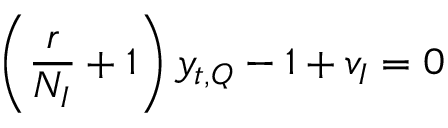<formula> <loc_0><loc_0><loc_500><loc_500>\left ( \frac { r } { N _ { I } } + 1 \right ) y _ { t , Q } - 1 + v _ { I } = 0</formula> 